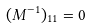Convert formula to latex. <formula><loc_0><loc_0><loc_500><loc_500>( M ^ { - 1 } ) _ { 1 1 } = 0</formula> 